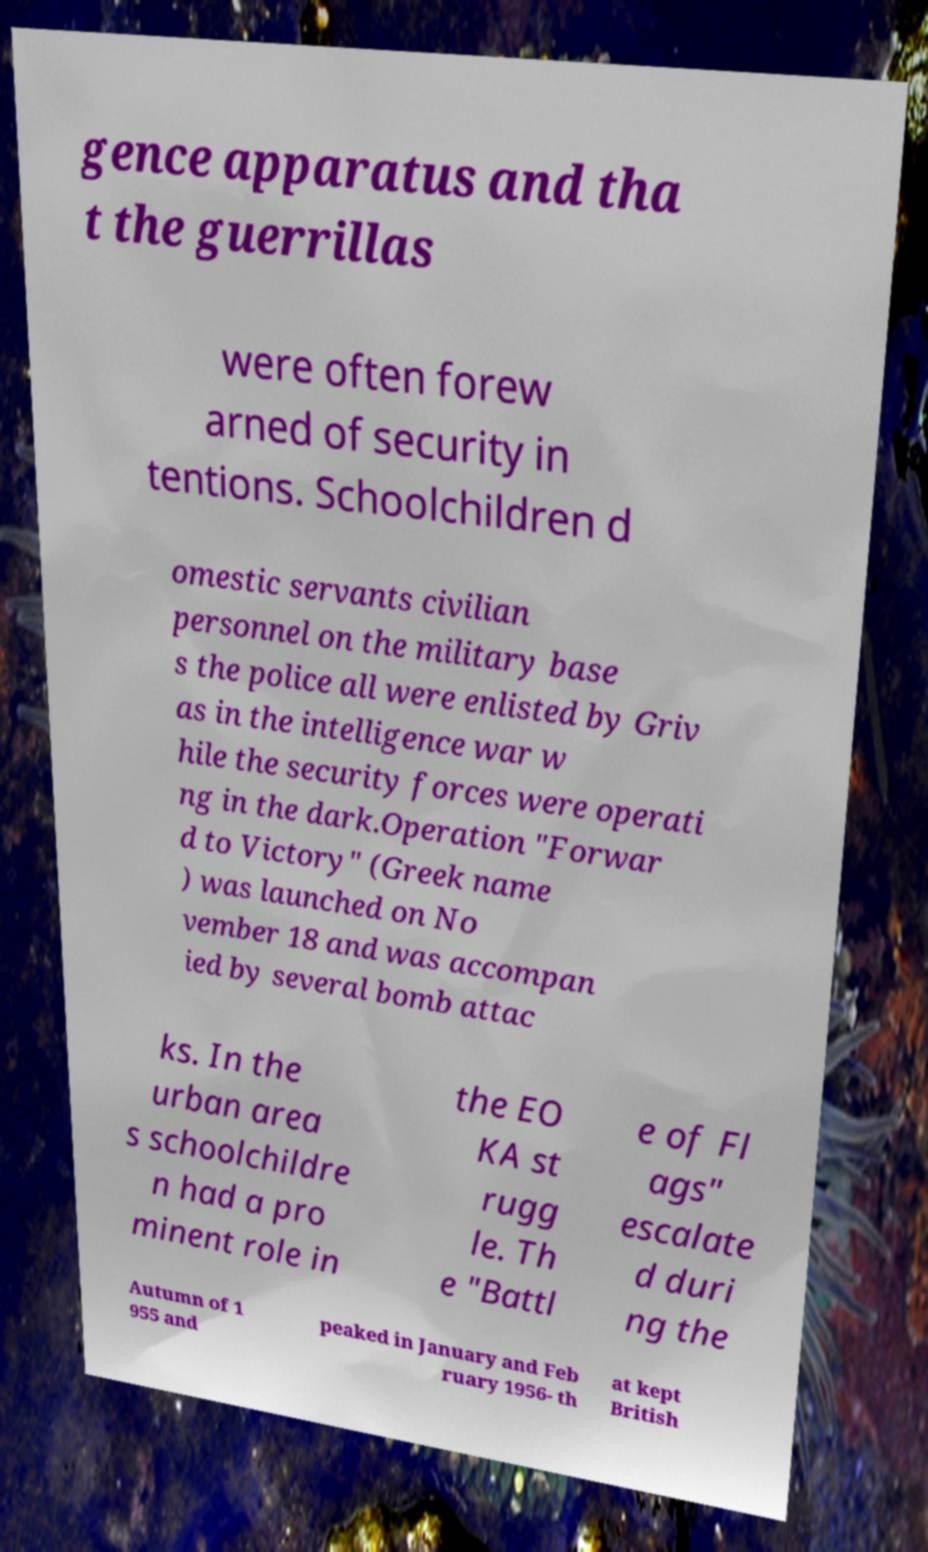Please read and relay the text visible in this image. What does it say? gence apparatus and tha t the guerrillas were often forew arned of security in tentions. Schoolchildren d omestic servants civilian personnel on the military base s the police all were enlisted by Griv as in the intelligence war w hile the security forces were operati ng in the dark.Operation "Forwar d to Victory" (Greek name ) was launched on No vember 18 and was accompan ied by several bomb attac ks. In the urban area s schoolchildre n had a pro minent role in the EO KA st rugg le. Th e "Battl e of Fl ags" escalate d duri ng the Autumn of 1 955 and peaked in January and Feb ruary 1956- th at kept British 